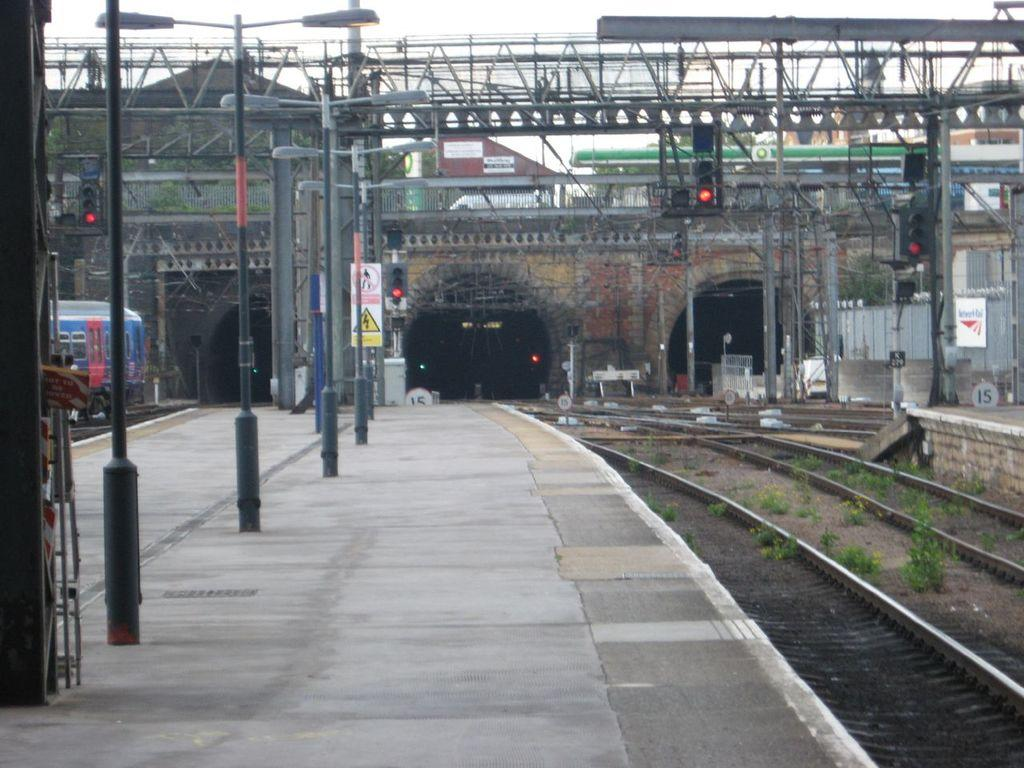What type of structures can be seen in the image? There are poles, boards, traffic signals, rods, a bridge, a platform, tunnels, and buildings visible in the image. What type of transportation infrastructure is present in the image? Railway tracks are present in the image. What type of vegetation can be seen in the image? There are plants visible in the image. What is visible in the background of the image? The sky is visible in the background of the image. What color of paint is being used on the school walls in the image? There is no school present in the image, so it is not possible to determine the color of paint being used on the walls. 